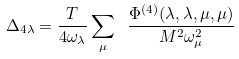<formula> <loc_0><loc_0><loc_500><loc_500>\Delta _ { 4 \lambda } = \frac { T } { 4 \omega _ { \lambda } } \sum _ { \mu } \ \frac { \Phi ^ { ( 4 ) } ( \lambda , \lambda , \mu , \mu ) } { M ^ { 2 } \omega _ { \mu } ^ { 2 } }</formula> 